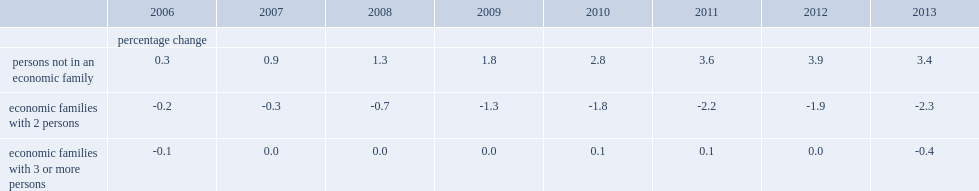The number of which kind of economic families observed little change in each of the years? Economic families with 3 or more persons. The number of which kind of economic families experienced consistently downward revisions in all of the years? Economic families with 2 persons. Whose number experienced consistently downward revisions in all of the years? Persons not in an economic family. 